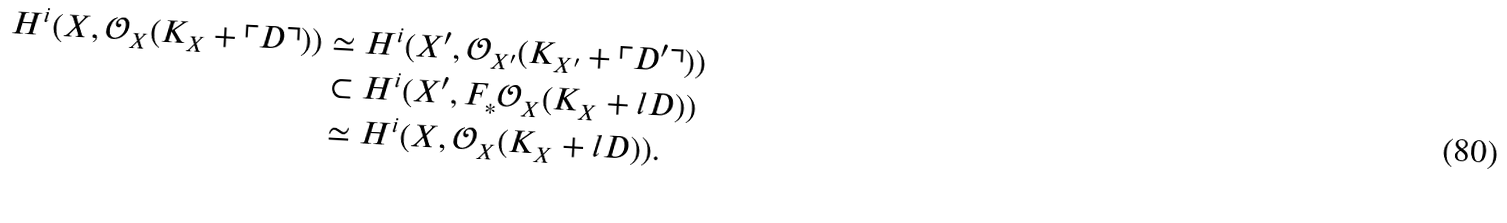Convert formula to latex. <formula><loc_0><loc_0><loc_500><loc_500>H ^ { i } ( X , \mathcal { O } _ { X } ( K _ { X } + \ulcorner D \urcorner ) ) & \simeq H ^ { i } ( X ^ { \prime } , \mathcal { O } _ { X ^ { \prime } } ( K _ { X ^ { \prime } } + \ulcorner D ^ { \prime } \urcorner ) ) \\ & \subset H ^ { i } ( X ^ { \prime } , F _ { * } \mathcal { O } _ { X } ( K _ { X } + l D ) ) \\ & \simeq H ^ { i } ( X , \mathcal { O } _ { X } ( K _ { X } + l D ) ) .</formula> 